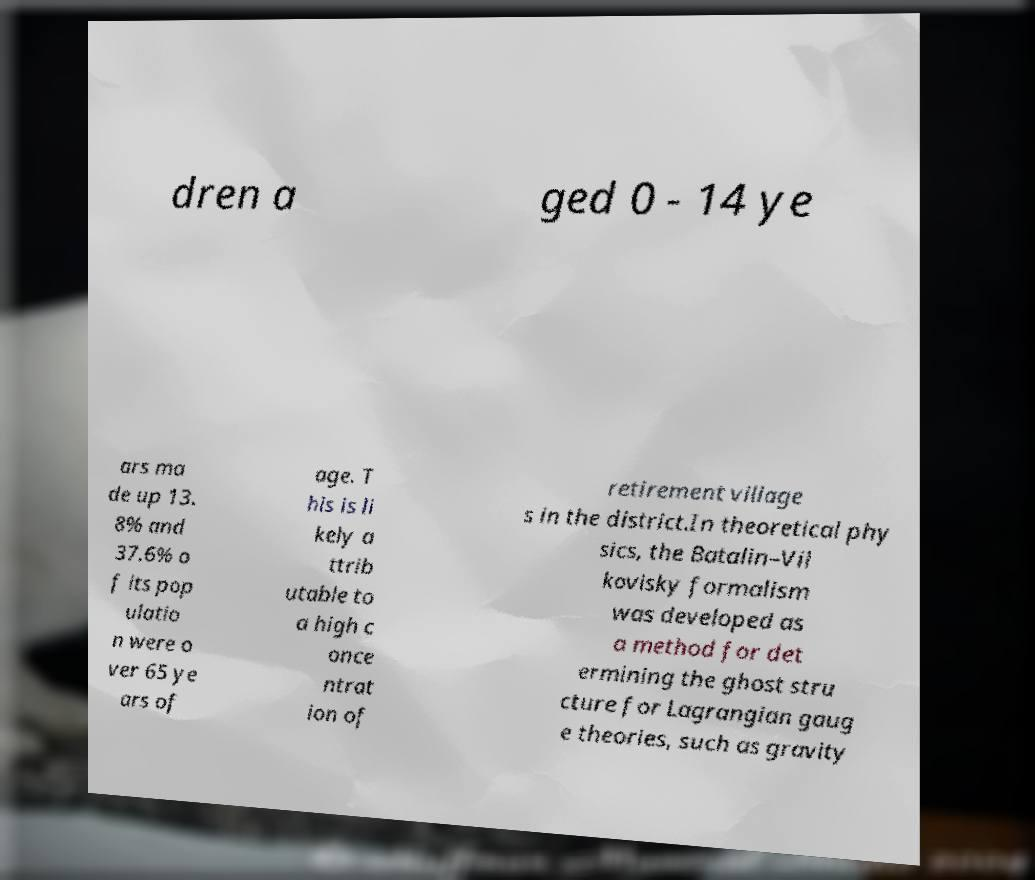For documentation purposes, I need the text within this image transcribed. Could you provide that? dren a ged 0 - 14 ye ars ma de up 13. 8% and 37.6% o f its pop ulatio n were o ver 65 ye ars of age. T his is li kely a ttrib utable to a high c once ntrat ion of retirement village s in the district.In theoretical phy sics, the Batalin–Vil kovisky formalism was developed as a method for det ermining the ghost stru cture for Lagrangian gaug e theories, such as gravity 